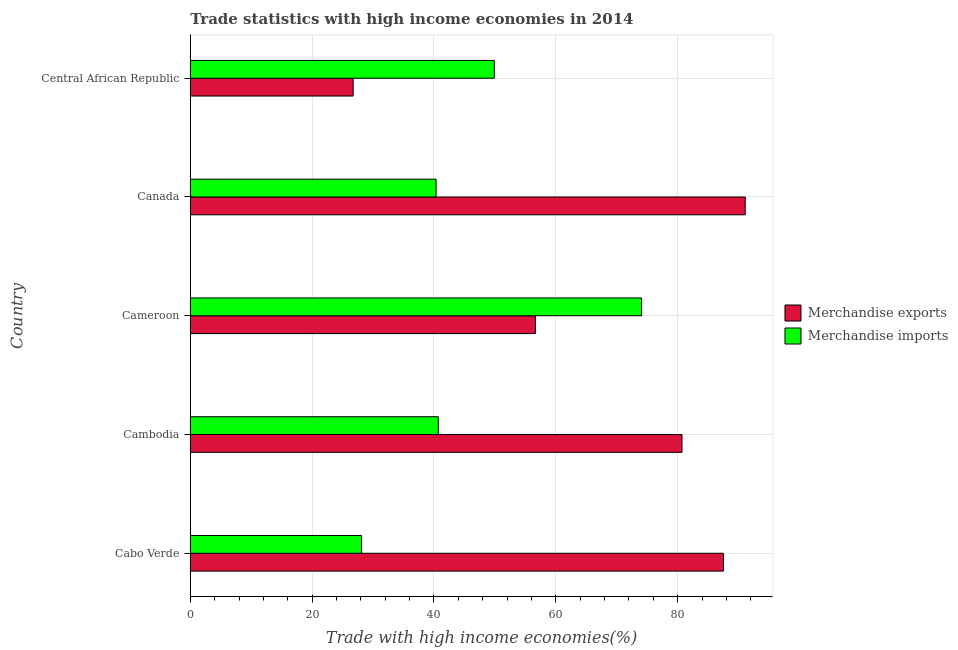How many groups of bars are there?
Your answer should be compact. 5. Are the number of bars per tick equal to the number of legend labels?
Provide a succinct answer. Yes. How many bars are there on the 1st tick from the top?
Your response must be concise. 2. What is the label of the 3rd group of bars from the top?
Your answer should be very brief. Cameroon. In how many cases, is the number of bars for a given country not equal to the number of legend labels?
Your answer should be compact. 0. What is the merchandise imports in Cabo Verde?
Offer a terse response. 28.11. Across all countries, what is the maximum merchandise imports?
Provide a succinct answer. 74.07. Across all countries, what is the minimum merchandise imports?
Provide a succinct answer. 28.11. In which country was the merchandise imports minimum?
Make the answer very short. Cabo Verde. What is the total merchandise exports in the graph?
Make the answer very short. 342.7. What is the difference between the merchandise exports in Cameroon and that in Canada?
Your answer should be very brief. -34.44. What is the difference between the merchandise exports in Canada and the merchandise imports in Cabo Verde?
Keep it short and to the point. 62.98. What is the average merchandise exports per country?
Your answer should be compact. 68.54. What is the difference between the merchandise exports and merchandise imports in Cabo Verde?
Offer a terse response. 59.41. What is the ratio of the merchandise exports in Cabo Verde to that in Central African Republic?
Your answer should be compact. 3.27. What is the difference between the highest and the second highest merchandise imports?
Provide a short and direct response. 24.17. What is the difference between the highest and the lowest merchandise exports?
Your response must be concise. 64.35. What does the 2nd bar from the bottom in Canada represents?
Offer a terse response. Merchandise imports. How many bars are there?
Offer a very short reply. 10. Are the values on the major ticks of X-axis written in scientific E-notation?
Provide a short and direct response. No. Does the graph contain grids?
Make the answer very short. Yes. Where does the legend appear in the graph?
Offer a terse response. Center right. What is the title of the graph?
Give a very brief answer. Trade statistics with high income economies in 2014. Does "Female labor force" appear as one of the legend labels in the graph?
Make the answer very short. No. What is the label or title of the X-axis?
Your answer should be compact. Trade with high income economies(%). What is the Trade with high income economies(%) of Merchandise exports in Cabo Verde?
Offer a terse response. 87.52. What is the Trade with high income economies(%) of Merchandise imports in Cabo Verde?
Provide a short and direct response. 28.11. What is the Trade with high income economies(%) in Merchandise exports in Cambodia?
Your answer should be very brief. 80.71. What is the Trade with high income economies(%) of Merchandise imports in Cambodia?
Give a very brief answer. 40.72. What is the Trade with high income economies(%) of Merchandise exports in Cameroon?
Ensure brevity in your answer.  56.65. What is the Trade with high income economies(%) of Merchandise imports in Cameroon?
Offer a terse response. 74.07. What is the Trade with high income economies(%) of Merchandise exports in Canada?
Give a very brief answer. 91.09. What is the Trade with high income economies(%) in Merchandise imports in Canada?
Offer a terse response. 40.35. What is the Trade with high income economies(%) in Merchandise exports in Central African Republic?
Offer a very short reply. 26.74. What is the Trade with high income economies(%) of Merchandise imports in Central African Republic?
Give a very brief answer. 49.91. Across all countries, what is the maximum Trade with high income economies(%) in Merchandise exports?
Keep it short and to the point. 91.09. Across all countries, what is the maximum Trade with high income economies(%) in Merchandise imports?
Ensure brevity in your answer.  74.07. Across all countries, what is the minimum Trade with high income economies(%) of Merchandise exports?
Your answer should be compact. 26.74. Across all countries, what is the minimum Trade with high income economies(%) in Merchandise imports?
Ensure brevity in your answer.  28.11. What is the total Trade with high income economies(%) in Merchandise exports in the graph?
Your answer should be compact. 342.7. What is the total Trade with high income economies(%) of Merchandise imports in the graph?
Make the answer very short. 233.15. What is the difference between the Trade with high income economies(%) in Merchandise exports in Cabo Verde and that in Cambodia?
Provide a short and direct response. 6.8. What is the difference between the Trade with high income economies(%) of Merchandise imports in Cabo Verde and that in Cambodia?
Your answer should be compact. -12.61. What is the difference between the Trade with high income economies(%) of Merchandise exports in Cabo Verde and that in Cameroon?
Ensure brevity in your answer.  30.87. What is the difference between the Trade with high income economies(%) in Merchandise imports in Cabo Verde and that in Cameroon?
Keep it short and to the point. -45.97. What is the difference between the Trade with high income economies(%) in Merchandise exports in Cabo Verde and that in Canada?
Provide a short and direct response. -3.57. What is the difference between the Trade with high income economies(%) in Merchandise imports in Cabo Verde and that in Canada?
Offer a very short reply. -12.24. What is the difference between the Trade with high income economies(%) in Merchandise exports in Cabo Verde and that in Central African Republic?
Your response must be concise. 60.78. What is the difference between the Trade with high income economies(%) of Merchandise imports in Cabo Verde and that in Central African Republic?
Ensure brevity in your answer.  -21.8. What is the difference between the Trade with high income economies(%) in Merchandise exports in Cambodia and that in Cameroon?
Your answer should be compact. 24.06. What is the difference between the Trade with high income economies(%) in Merchandise imports in Cambodia and that in Cameroon?
Your response must be concise. -33.36. What is the difference between the Trade with high income economies(%) in Merchandise exports in Cambodia and that in Canada?
Offer a terse response. -10.38. What is the difference between the Trade with high income economies(%) in Merchandise imports in Cambodia and that in Canada?
Provide a short and direct response. 0.37. What is the difference between the Trade with high income economies(%) of Merchandise exports in Cambodia and that in Central African Republic?
Your response must be concise. 53.98. What is the difference between the Trade with high income economies(%) of Merchandise imports in Cambodia and that in Central African Republic?
Your answer should be compact. -9.19. What is the difference between the Trade with high income economies(%) in Merchandise exports in Cameroon and that in Canada?
Make the answer very short. -34.44. What is the difference between the Trade with high income economies(%) in Merchandise imports in Cameroon and that in Canada?
Ensure brevity in your answer.  33.73. What is the difference between the Trade with high income economies(%) of Merchandise exports in Cameroon and that in Central African Republic?
Offer a terse response. 29.91. What is the difference between the Trade with high income economies(%) of Merchandise imports in Cameroon and that in Central African Republic?
Provide a short and direct response. 24.17. What is the difference between the Trade with high income economies(%) in Merchandise exports in Canada and that in Central African Republic?
Ensure brevity in your answer.  64.35. What is the difference between the Trade with high income economies(%) of Merchandise imports in Canada and that in Central African Republic?
Give a very brief answer. -9.56. What is the difference between the Trade with high income economies(%) in Merchandise exports in Cabo Verde and the Trade with high income economies(%) in Merchandise imports in Cambodia?
Your answer should be very brief. 46.8. What is the difference between the Trade with high income economies(%) in Merchandise exports in Cabo Verde and the Trade with high income economies(%) in Merchandise imports in Cameroon?
Give a very brief answer. 13.44. What is the difference between the Trade with high income economies(%) of Merchandise exports in Cabo Verde and the Trade with high income economies(%) of Merchandise imports in Canada?
Provide a succinct answer. 47.17. What is the difference between the Trade with high income economies(%) of Merchandise exports in Cabo Verde and the Trade with high income economies(%) of Merchandise imports in Central African Republic?
Offer a terse response. 37.61. What is the difference between the Trade with high income economies(%) in Merchandise exports in Cambodia and the Trade with high income economies(%) in Merchandise imports in Cameroon?
Offer a terse response. 6.64. What is the difference between the Trade with high income economies(%) in Merchandise exports in Cambodia and the Trade with high income economies(%) in Merchandise imports in Canada?
Ensure brevity in your answer.  40.37. What is the difference between the Trade with high income economies(%) of Merchandise exports in Cambodia and the Trade with high income economies(%) of Merchandise imports in Central African Republic?
Provide a succinct answer. 30.81. What is the difference between the Trade with high income economies(%) in Merchandise exports in Cameroon and the Trade with high income economies(%) in Merchandise imports in Canada?
Give a very brief answer. 16.3. What is the difference between the Trade with high income economies(%) of Merchandise exports in Cameroon and the Trade with high income economies(%) of Merchandise imports in Central African Republic?
Offer a terse response. 6.74. What is the difference between the Trade with high income economies(%) of Merchandise exports in Canada and the Trade with high income economies(%) of Merchandise imports in Central African Republic?
Your response must be concise. 41.18. What is the average Trade with high income economies(%) of Merchandise exports per country?
Give a very brief answer. 68.54. What is the average Trade with high income economies(%) in Merchandise imports per country?
Offer a very short reply. 46.63. What is the difference between the Trade with high income economies(%) of Merchandise exports and Trade with high income economies(%) of Merchandise imports in Cabo Verde?
Your response must be concise. 59.41. What is the difference between the Trade with high income economies(%) of Merchandise exports and Trade with high income economies(%) of Merchandise imports in Cambodia?
Ensure brevity in your answer.  40. What is the difference between the Trade with high income economies(%) of Merchandise exports and Trade with high income economies(%) of Merchandise imports in Cameroon?
Your response must be concise. -17.42. What is the difference between the Trade with high income economies(%) of Merchandise exports and Trade with high income economies(%) of Merchandise imports in Canada?
Ensure brevity in your answer.  50.74. What is the difference between the Trade with high income economies(%) in Merchandise exports and Trade with high income economies(%) in Merchandise imports in Central African Republic?
Your answer should be very brief. -23.17. What is the ratio of the Trade with high income economies(%) in Merchandise exports in Cabo Verde to that in Cambodia?
Your answer should be compact. 1.08. What is the ratio of the Trade with high income economies(%) in Merchandise imports in Cabo Verde to that in Cambodia?
Your answer should be very brief. 0.69. What is the ratio of the Trade with high income economies(%) of Merchandise exports in Cabo Verde to that in Cameroon?
Your answer should be very brief. 1.54. What is the ratio of the Trade with high income economies(%) of Merchandise imports in Cabo Verde to that in Cameroon?
Your response must be concise. 0.38. What is the ratio of the Trade with high income economies(%) in Merchandise exports in Cabo Verde to that in Canada?
Offer a very short reply. 0.96. What is the ratio of the Trade with high income economies(%) of Merchandise imports in Cabo Verde to that in Canada?
Offer a very short reply. 0.7. What is the ratio of the Trade with high income economies(%) in Merchandise exports in Cabo Verde to that in Central African Republic?
Keep it short and to the point. 3.27. What is the ratio of the Trade with high income economies(%) of Merchandise imports in Cabo Verde to that in Central African Republic?
Your answer should be very brief. 0.56. What is the ratio of the Trade with high income economies(%) of Merchandise exports in Cambodia to that in Cameroon?
Offer a very short reply. 1.42. What is the ratio of the Trade with high income economies(%) in Merchandise imports in Cambodia to that in Cameroon?
Provide a short and direct response. 0.55. What is the ratio of the Trade with high income economies(%) of Merchandise exports in Cambodia to that in Canada?
Your response must be concise. 0.89. What is the ratio of the Trade with high income economies(%) in Merchandise imports in Cambodia to that in Canada?
Provide a short and direct response. 1.01. What is the ratio of the Trade with high income economies(%) of Merchandise exports in Cambodia to that in Central African Republic?
Ensure brevity in your answer.  3.02. What is the ratio of the Trade with high income economies(%) of Merchandise imports in Cambodia to that in Central African Republic?
Offer a very short reply. 0.82. What is the ratio of the Trade with high income economies(%) of Merchandise exports in Cameroon to that in Canada?
Your answer should be very brief. 0.62. What is the ratio of the Trade with high income economies(%) in Merchandise imports in Cameroon to that in Canada?
Make the answer very short. 1.84. What is the ratio of the Trade with high income economies(%) in Merchandise exports in Cameroon to that in Central African Republic?
Provide a short and direct response. 2.12. What is the ratio of the Trade with high income economies(%) of Merchandise imports in Cameroon to that in Central African Republic?
Provide a succinct answer. 1.48. What is the ratio of the Trade with high income economies(%) of Merchandise exports in Canada to that in Central African Republic?
Keep it short and to the point. 3.41. What is the ratio of the Trade with high income economies(%) of Merchandise imports in Canada to that in Central African Republic?
Your answer should be compact. 0.81. What is the difference between the highest and the second highest Trade with high income economies(%) in Merchandise exports?
Your answer should be very brief. 3.57. What is the difference between the highest and the second highest Trade with high income economies(%) of Merchandise imports?
Your answer should be very brief. 24.17. What is the difference between the highest and the lowest Trade with high income economies(%) of Merchandise exports?
Your answer should be compact. 64.35. What is the difference between the highest and the lowest Trade with high income economies(%) of Merchandise imports?
Offer a very short reply. 45.97. 